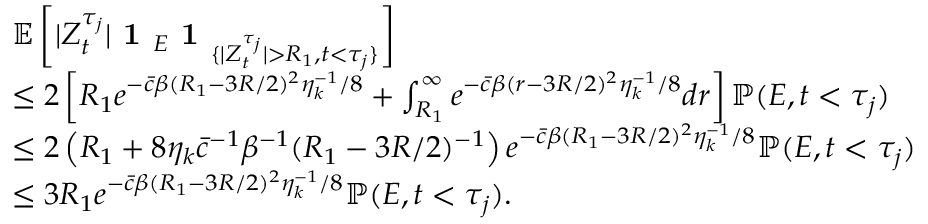Convert formula to latex. <formula><loc_0><loc_0><loc_500><loc_500>\begin{array} { r l } & { \mathbb { E } \left [ | Z _ { t } ^ { \tau _ { j } } | 1 _ { E } 1 _ { \{ | Z _ { t } ^ { \tau _ { j } } | > R _ { 1 } , t < \tau _ { j } \} } \right ] } \\ & { \leq 2 \left [ R _ { 1 } e ^ { - \bar { c } \beta ( R _ { 1 } - 3 R / 2 ) ^ { 2 } \eta _ { k } ^ { - 1 } / 8 } + \int _ { R _ { 1 } } ^ { \infty } e ^ { - \bar { c } \beta ( r - 3 R / 2 ) ^ { 2 } \eta _ { k } ^ { - 1 } / 8 } d r \right ] \mathbb { P } ( E , t < \tau _ { j } ) } \\ & { \leq 2 \left ( R _ { 1 } + 8 \eta _ { k } \bar { c } ^ { - 1 } \beta ^ { - 1 } ( R _ { 1 } - 3 R / 2 ) ^ { - 1 } \right ) e ^ { - \bar { c } \beta ( R _ { 1 } - 3 R / 2 ) ^ { 2 } \eta _ { k } ^ { - 1 } / 8 } \mathbb { P } ( E , t < \tau _ { j } ) } \\ & { \leq 3 R _ { 1 } e ^ { - \bar { c } \beta ( R _ { 1 } - 3 R / 2 ) ^ { 2 } \eta _ { k } ^ { - 1 } / 8 } \mathbb { P } ( E , t < \tau _ { j } ) . } \end{array}</formula> 